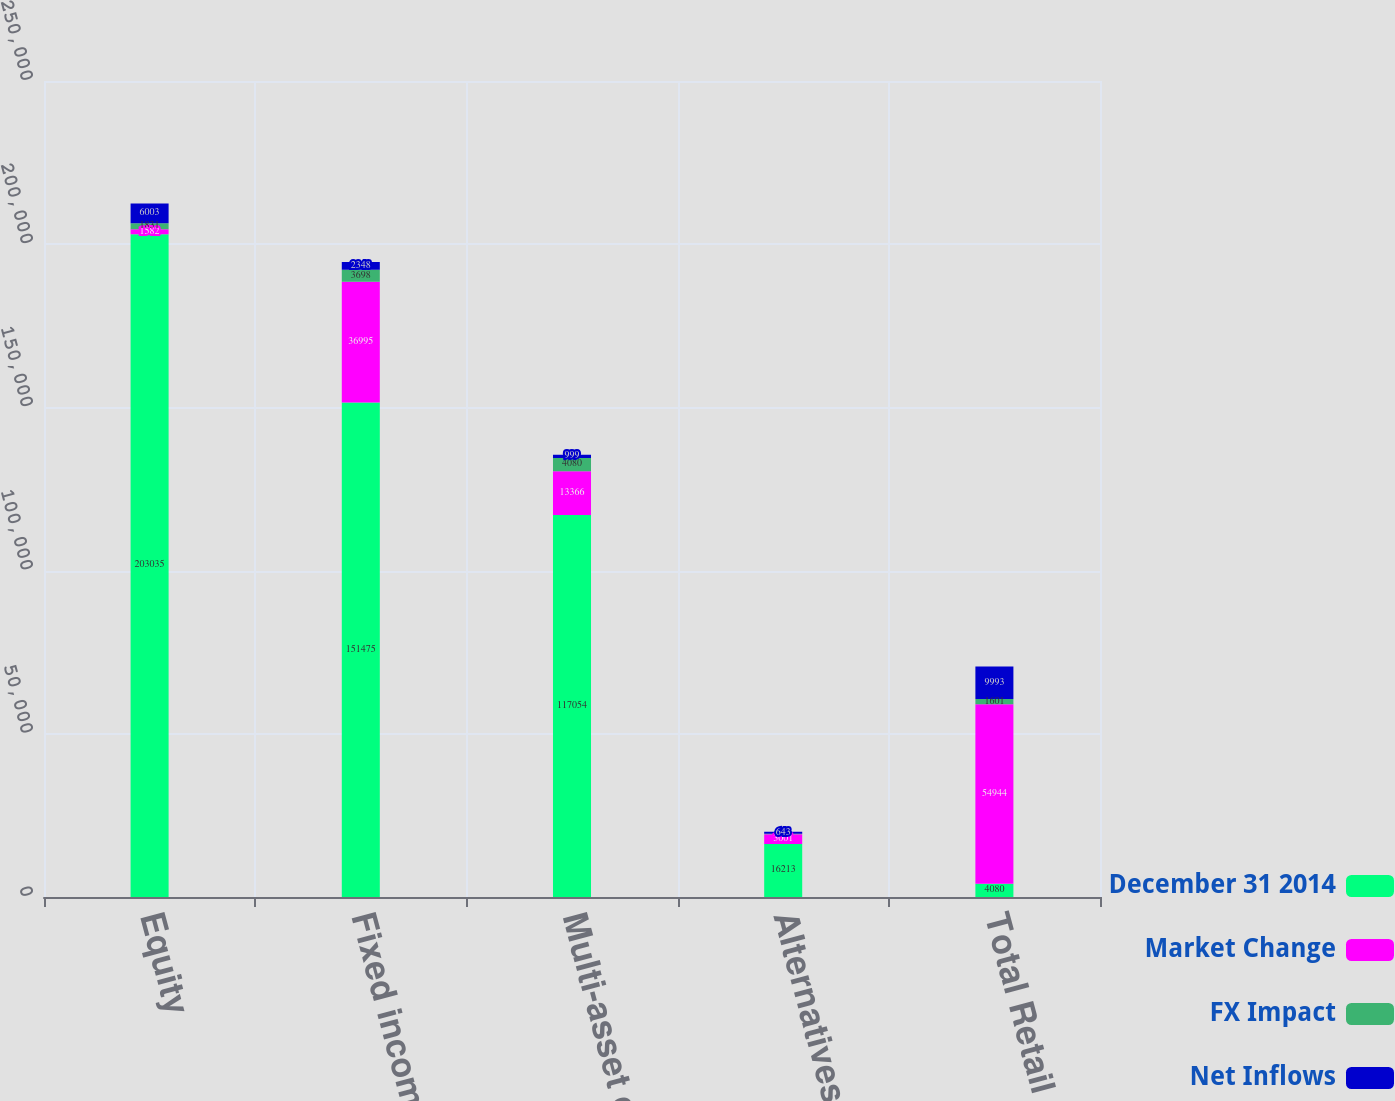Convert chart to OTSL. <chart><loc_0><loc_0><loc_500><loc_500><stacked_bar_chart><ecel><fcel>Equity<fcel>Fixed income<fcel>Multi-asset class<fcel>Alternatives<fcel>Total Retail<nl><fcel>December 31 2014<fcel>203035<fcel>151475<fcel>117054<fcel>16213<fcel>4080<nl><fcel>Market Change<fcel>1582<fcel>36995<fcel>13366<fcel>3001<fcel>54944<nl><fcel>FX Impact<fcel>1831<fcel>3698<fcel>4080<fcel>152<fcel>1601<nl><fcel>Net Inflows<fcel>6003<fcel>2348<fcel>999<fcel>643<fcel>9993<nl></chart> 